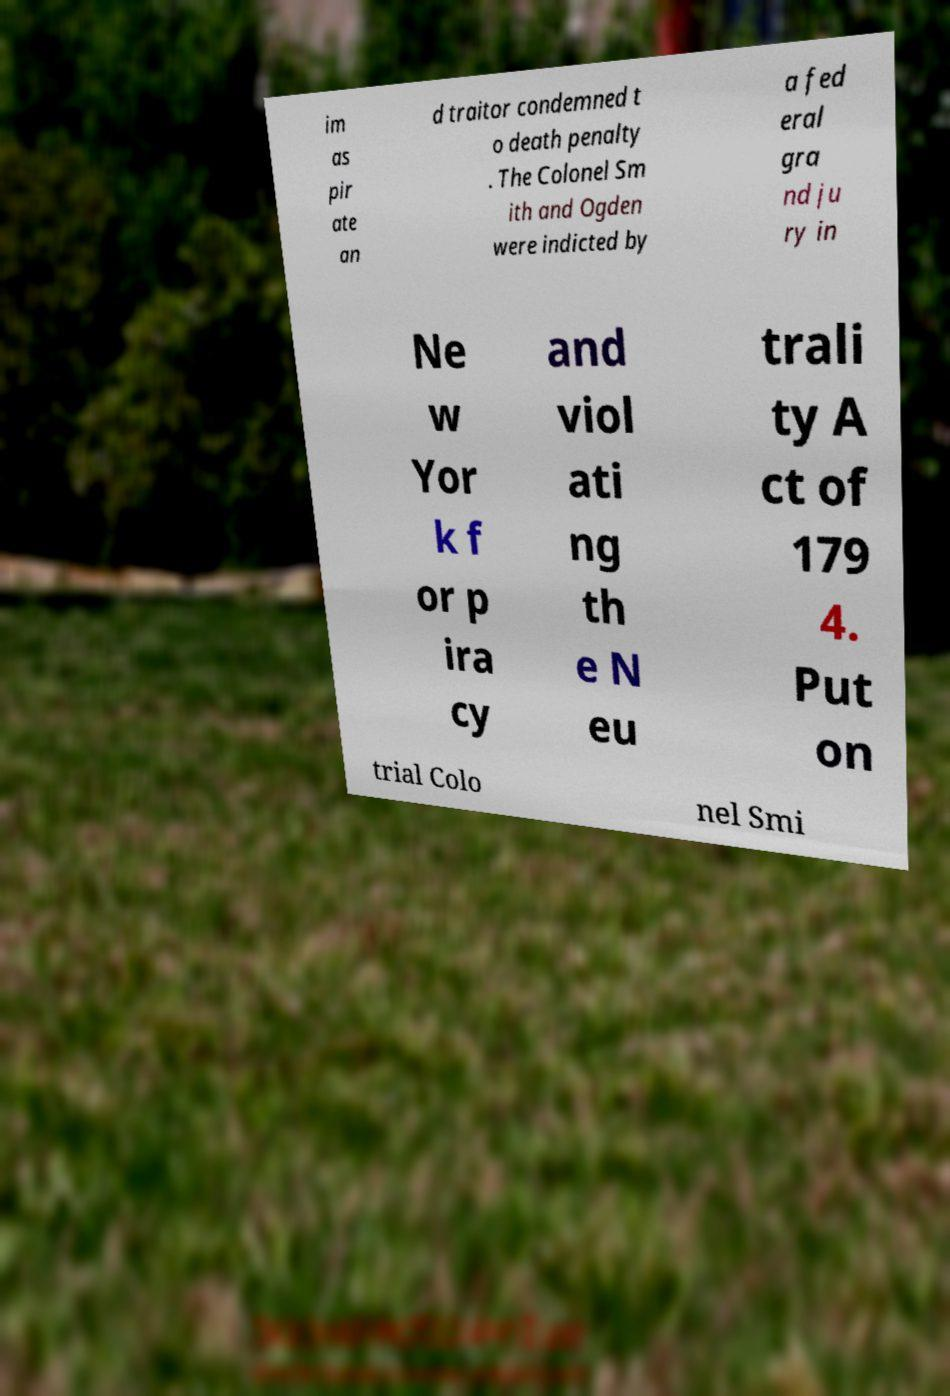I need the written content from this picture converted into text. Can you do that? im as pir ate an d traitor condemned t o death penalty . The Colonel Sm ith and Ogden were indicted by a fed eral gra nd ju ry in Ne w Yor k f or p ira cy and viol ati ng th e N eu trali ty A ct of 179 4. Put on trial Colo nel Smi 